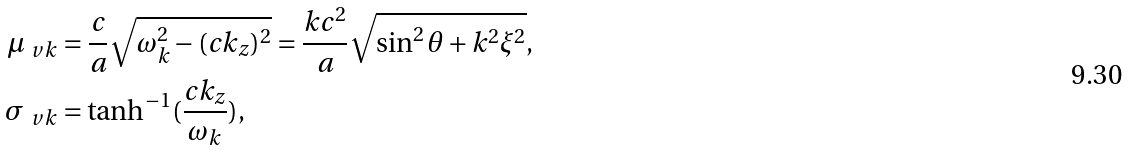<formula> <loc_0><loc_0><loc_500><loc_500>\mu _ { \ v k } & = \frac { c } { a } \sqrt { \omega _ { k } ^ { 2 } - ( c k _ { z } ) ^ { 2 } } = \frac { k c ^ { 2 } } { a } \sqrt { \sin ^ { 2 } \theta + k ^ { 2 } \xi ^ { 2 } } , \\ \sigma _ { \ v k } & = \tanh ^ { - 1 } ( \frac { c k _ { z } } { \omega _ { k } } ) ,</formula> 